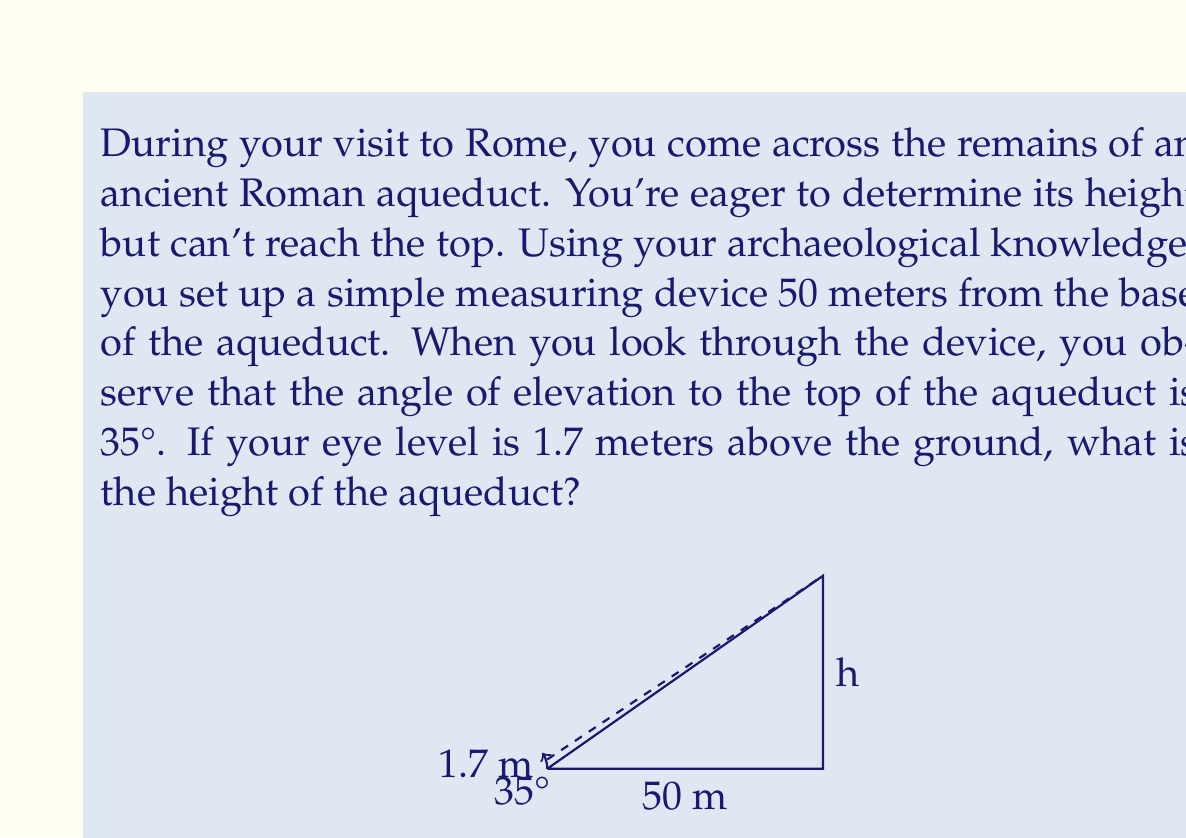Help me with this question. Let's approach this problem step-by-step using trigonometry:

1) First, let's identify the known values:
   - Distance from the observer to the aqueduct: 50 meters
   - Angle of elevation: 35°
   - Observer's eye level: 1.7 meters

2) We can use the tangent function to find the height. The tangent of an angle in a right triangle is the ratio of the opposite side to the adjacent side.

3) Let $h$ be the height of the aqueduct above the observer's eye level. Then:

   $$\tan(35°) = \frac{h}{50}$$

4) Solving for $h$:

   $$h = 50 \tan(35°)$$

5) Using a calculator (or trigonometric tables):

   $$h = 50 \cdot 0.7002 = 35.01 \text{ meters}$$

6) This is the height above the observer's eye level. To get the total height of the aqueduct, we need to add the observer's eye level:

   $$\text{Total height} = 35.01 + 1.7 = 36.71 \text{ meters}$$

7) Rounding to two decimal places for a reasonable level of precision:

   $$\text{Height of the aqueduct} = 36.71 \text{ meters}$$
Answer: 36.71 meters 